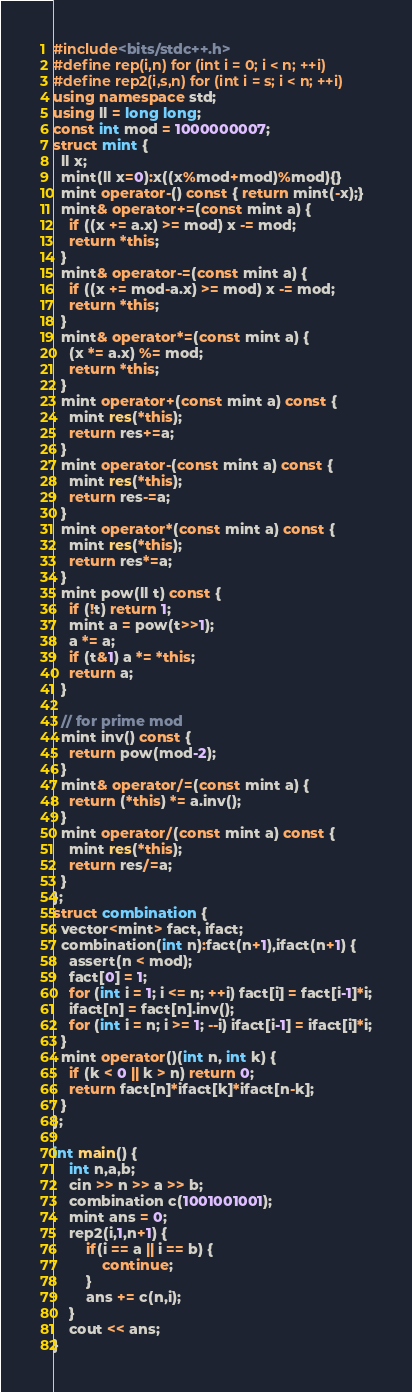<code> <loc_0><loc_0><loc_500><loc_500><_C++_>#include<bits/stdc++.h>
#define rep(i,n) for (int i = 0; i < n; ++i)
#define rep2(i,s,n) for (int i = s; i < n; ++i)
using namespace std;
using ll = long long;
const int mod = 1000000007;
struct mint {
  ll x;
  mint(ll x=0):x((x%mod+mod)%mod){}
  mint operator-() const { return mint(-x);}
  mint& operator+=(const mint a) {
    if ((x += a.x) >= mod) x -= mod;
    return *this;
  }
  mint& operator-=(const mint a) {
    if ((x += mod-a.x) >= mod) x -= mod;
    return *this;
  }
  mint& operator*=(const mint a) {
    (x *= a.x) %= mod;
    return *this;
  }
  mint operator+(const mint a) const {
    mint res(*this);
    return res+=a;
  }
  mint operator-(const mint a) const {
    mint res(*this);
    return res-=a;
  }
  mint operator*(const mint a) const {
    mint res(*this);
    return res*=a;
  }
  mint pow(ll t) const {
    if (!t) return 1;
    mint a = pow(t>>1);
    a *= a;
    if (t&1) a *= *this;
    return a;
  }

  // for prime mod
  mint inv() const {
    return pow(mod-2);
  }
  mint& operator/=(const mint a) {
    return (*this) *= a.inv();
  }
  mint operator/(const mint a) const {
    mint res(*this);
    return res/=a;
  }
};
struct combination {
  vector<mint> fact, ifact;
  combination(int n):fact(n+1),ifact(n+1) {
    assert(n < mod);
    fact[0] = 1;
    for (int i = 1; i <= n; ++i) fact[i] = fact[i-1]*i;
    ifact[n] = fact[n].inv();
    for (int i = n; i >= 1; --i) ifact[i-1] = ifact[i]*i;
  }
  mint operator()(int n, int k) {
    if (k < 0 || k > n) return 0;
    return fact[n]*ifact[k]*ifact[n-k];
  }
};

int main() {
    int n,a,b;
    cin >> n >> a >> b;
    combination c(1001001001);
    mint ans = 0;
    rep2(i,1,n+1) {
        if(i == a || i == b) {
            continue;
        } 
        ans += c(n,i);
    }
    cout << ans;
}</code> 